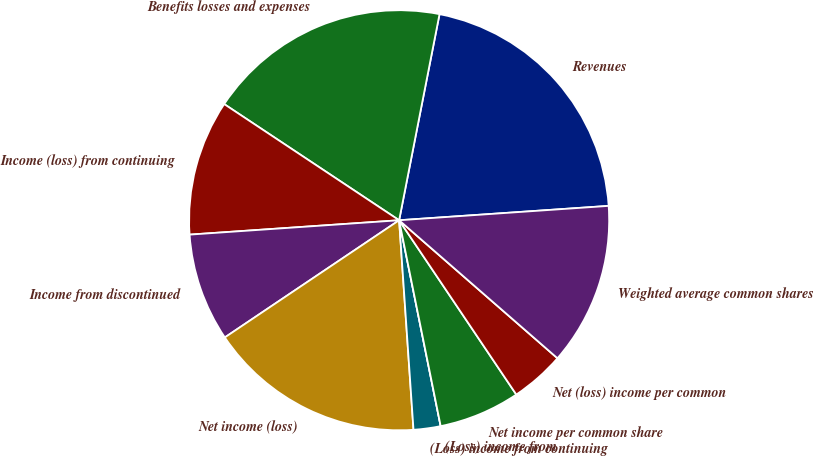Convert chart. <chart><loc_0><loc_0><loc_500><loc_500><pie_chart><fcel>Revenues<fcel>Benefits losses and expenses<fcel>Income (loss) from continuing<fcel>Income from discontinued<fcel>Net income (loss)<fcel>(Loss) income from continuing<fcel>(Loss) income from<fcel>Net income per common share<fcel>Net (loss) income per common<fcel>Weighted average common shares<nl><fcel>20.83%<fcel>18.75%<fcel>10.42%<fcel>8.33%<fcel>16.67%<fcel>2.08%<fcel>0.0%<fcel>6.25%<fcel>4.17%<fcel>12.5%<nl></chart> 